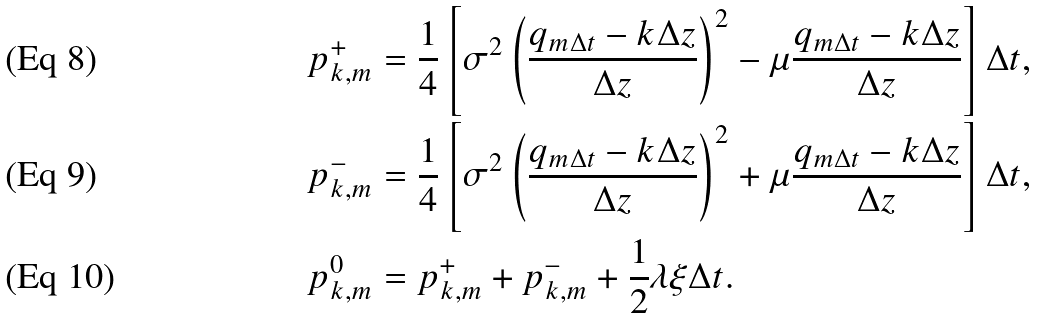Convert formula to latex. <formula><loc_0><loc_0><loc_500><loc_500>p _ { k , m } ^ { + } & = \frac { 1 } { 4 } \left [ \sigma ^ { 2 } \left ( \frac { q _ { m \Delta t } - k \Delta z } { \Delta z } \right ) ^ { 2 } - \mu \frac { q _ { m \Delta t } - k \Delta z } { \Delta z } \right ] \Delta t , \\ p _ { k , m } ^ { - } & = \frac { 1 } { 4 } \left [ \sigma ^ { 2 } \left ( \frac { q _ { m \Delta t } - k \Delta z } { \Delta z } \right ) ^ { 2 } + \mu \frac { q _ { m \Delta t } - k \Delta z } { \Delta z } \right ] \Delta t , \\ p _ { k , m } ^ { 0 } & = p _ { k , m } ^ { + } + p _ { k , m } ^ { - } + \frac { 1 } { 2 } \lambda \xi \Delta t .</formula> 